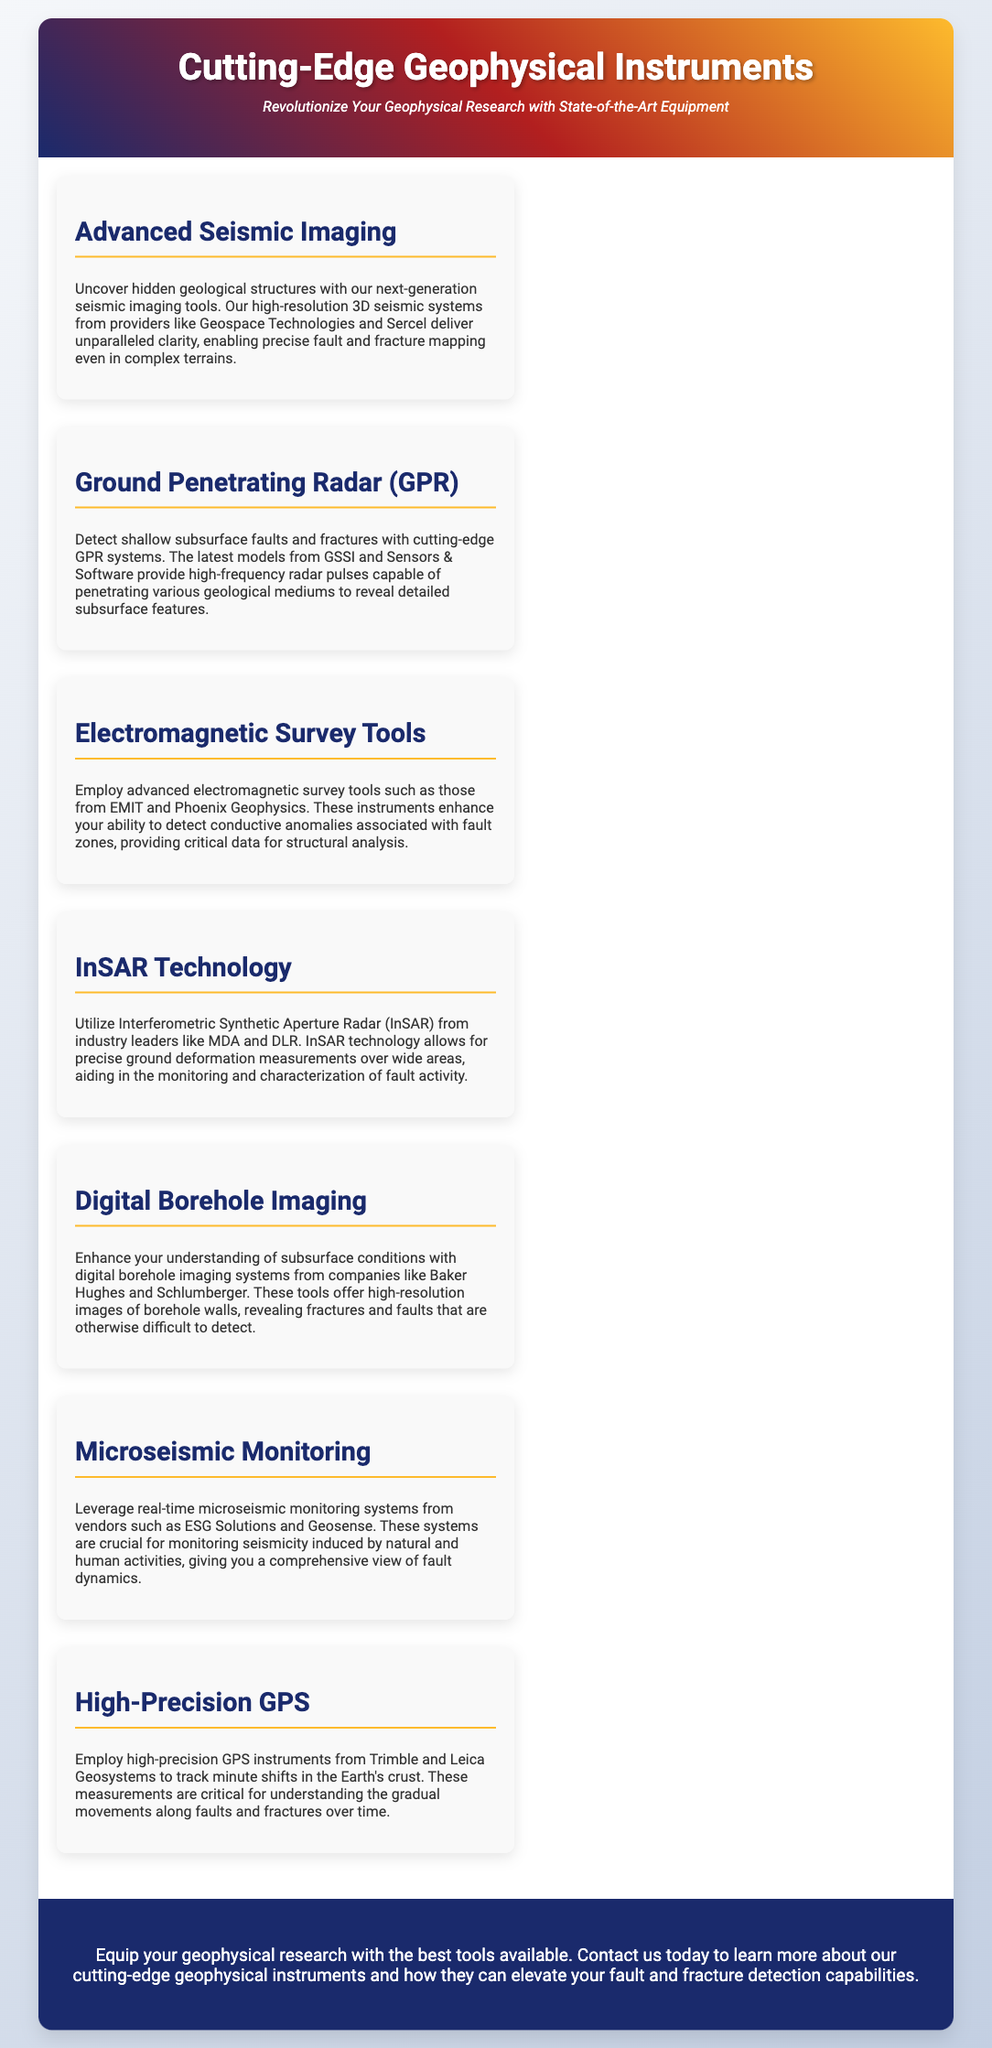what is the title of the advertisement? The title of the advertisement clearly states "Cutting-Edge Geophysical Instruments."
Answer: Cutting-Edge Geophysical Instruments who are two equipment providers mentioned for seismic imaging? The document mentions Geospace Technologies and Sercel as providers for seismic imaging.
Answer: Geospace Technologies, Sercel which technology helps in monitoring ground deformation? The document specifies that InSAR technology is utilized for precise ground deformation measurements.
Answer: InSAR Technology what is the purpose of high-precision GPS instruments? The document explains that high-precision GPS instruments track minute shifts in the Earth's crust.
Answer: Track minute shifts which tool enhances the understanding of subsurface conditions? The document states that digital borehole imaging systems enhance understanding of subsurface conditions.
Answer: Digital Borehole Imaging how many sections are listed in the document? Upon review, there are seven sections dedicated to different types of geophysical instruments.
Answer: Seven which company is mentioned for Ground Penetrating Radar systems? The document lists GSSI as one of the companies providing Ground Penetrating Radar systems.
Answer: GSSI what is the call-to-action in the advertisement? The call-to-action encourages contacting the company to learn more about the cutting-edge geophysical instruments.
Answer: Contact us today to learn more 